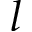Convert formula to latex. <formula><loc_0><loc_0><loc_500><loc_500>l</formula> 